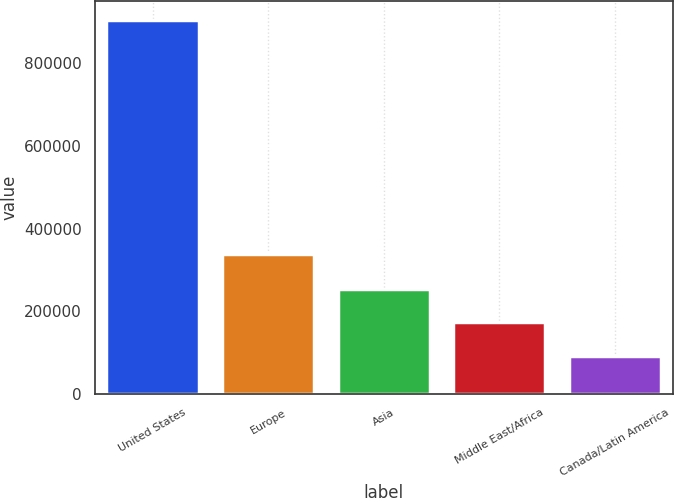Convert chart to OTSL. <chart><loc_0><loc_0><loc_500><loc_500><bar_chart><fcel>United States<fcel>Europe<fcel>Asia<fcel>Middle East/Africa<fcel>Canada/Latin America<nl><fcel>903582<fcel>338805<fcel>255098<fcel>174038<fcel>92977<nl></chart> 